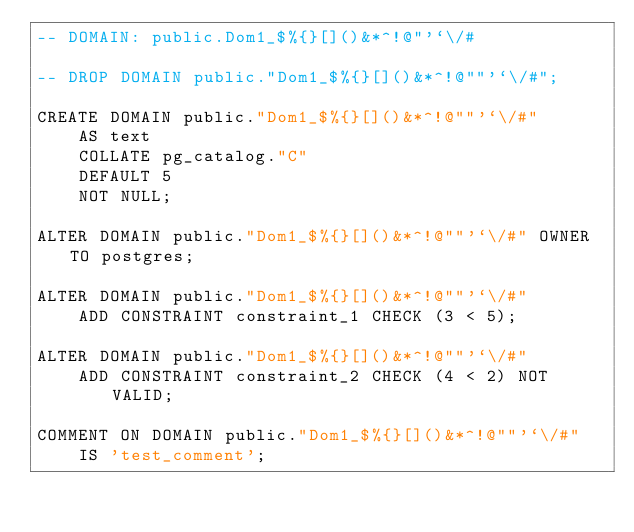<code> <loc_0><loc_0><loc_500><loc_500><_SQL_>-- DOMAIN: public.Dom1_$%{}[]()&*^!@"'`\/#

-- DROP DOMAIN public."Dom1_$%{}[]()&*^!@""'`\/#";

CREATE DOMAIN public."Dom1_$%{}[]()&*^!@""'`\/#"
    AS text
    COLLATE pg_catalog."C"
    DEFAULT 5
    NOT NULL;

ALTER DOMAIN public."Dom1_$%{}[]()&*^!@""'`\/#" OWNER TO postgres;

ALTER DOMAIN public."Dom1_$%{}[]()&*^!@""'`\/#"
    ADD CONSTRAINT constraint_1 CHECK (3 < 5);

ALTER DOMAIN public."Dom1_$%{}[]()&*^!@""'`\/#"
    ADD CONSTRAINT constraint_2 CHECK (4 < 2) NOT VALID;

COMMENT ON DOMAIN public."Dom1_$%{}[]()&*^!@""'`\/#"
    IS 'test_comment';
</code> 